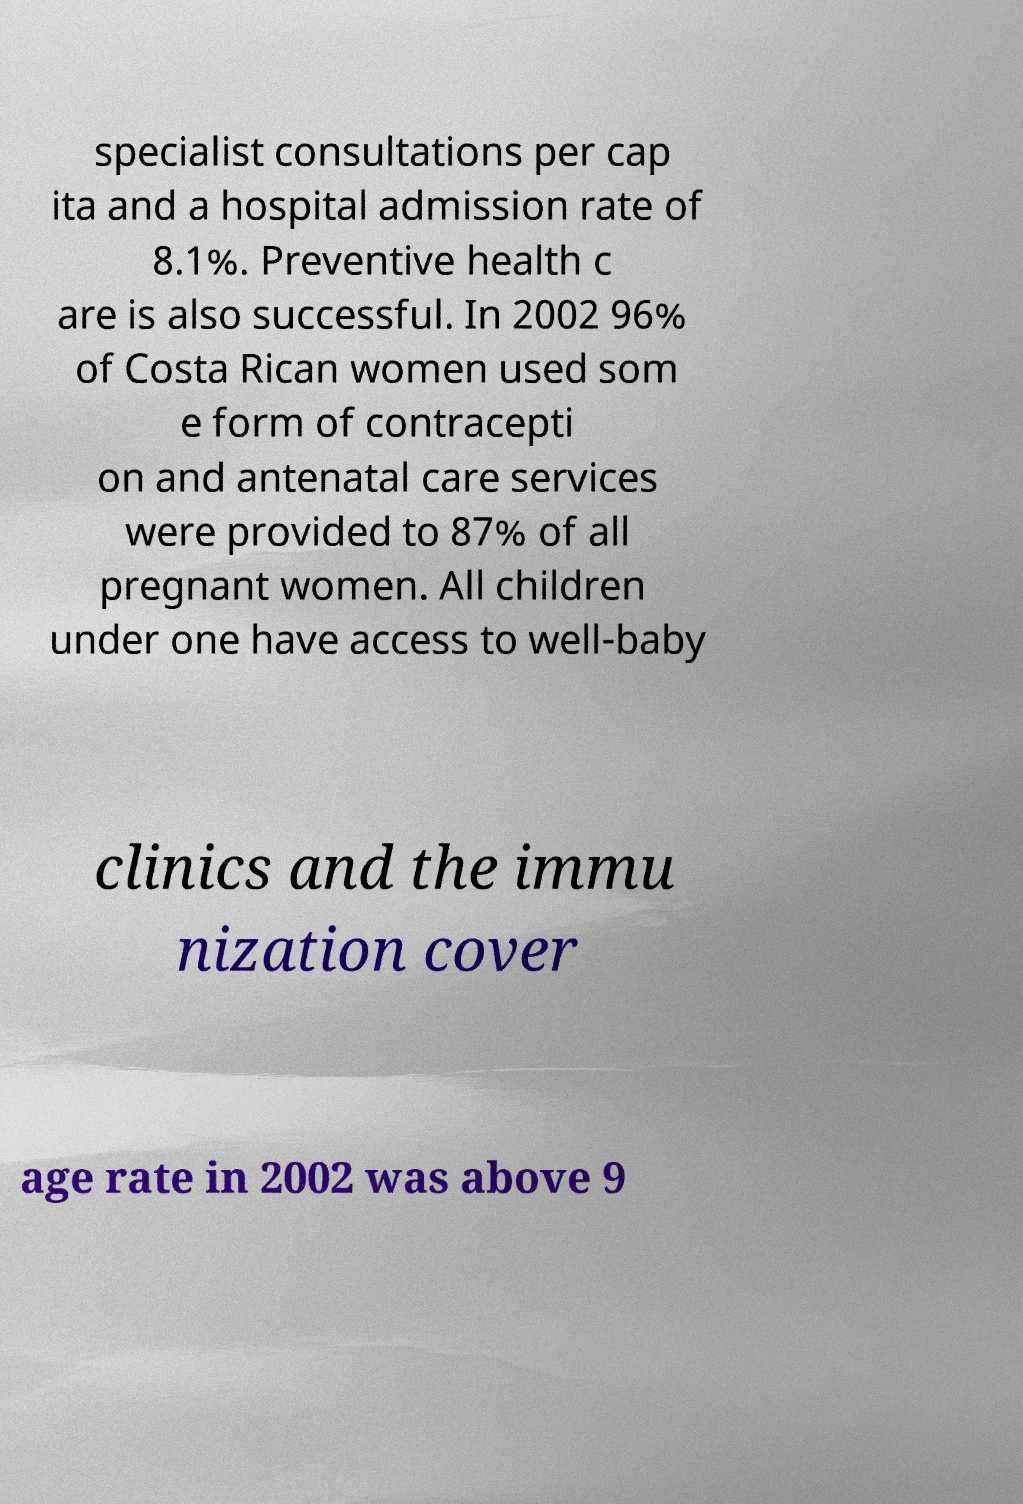There's text embedded in this image that I need extracted. Can you transcribe it verbatim? specialist consultations per cap ita and a hospital admission rate of 8.1%. Preventive health c are is also successful. In 2002 96% of Costa Rican women used som e form of contracepti on and antenatal care services were provided to 87% of all pregnant women. All children under one have access to well-baby clinics and the immu nization cover age rate in 2002 was above 9 